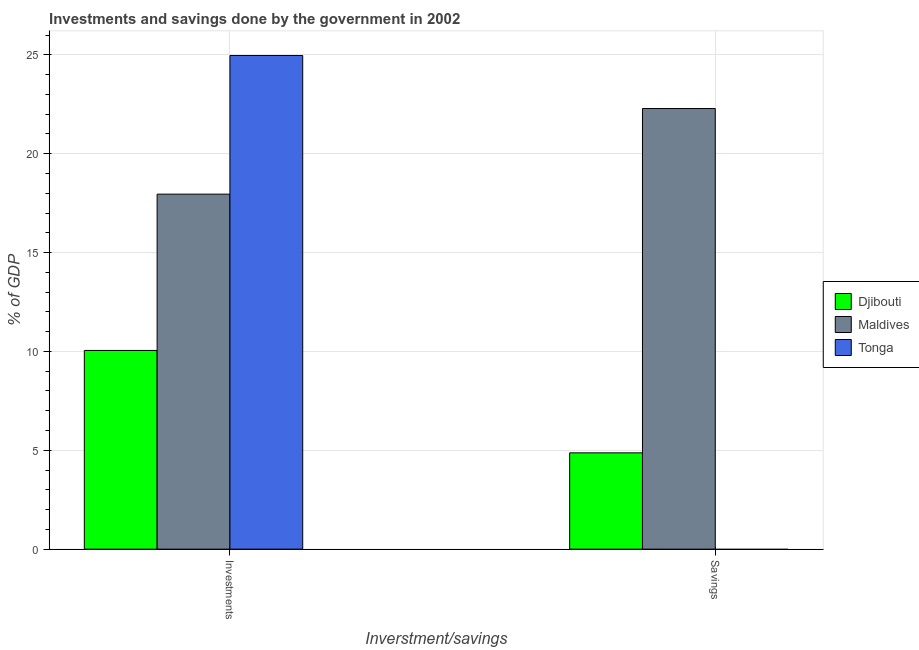How many groups of bars are there?
Provide a short and direct response. 2. Are the number of bars per tick equal to the number of legend labels?
Keep it short and to the point. No. How many bars are there on the 2nd tick from the right?
Offer a very short reply. 3. What is the label of the 2nd group of bars from the left?
Provide a succinct answer. Savings. What is the savings of government in Tonga?
Your response must be concise. 0. Across all countries, what is the maximum savings of government?
Your response must be concise. 22.29. In which country was the investments of government maximum?
Offer a terse response. Tonga. What is the total savings of government in the graph?
Make the answer very short. 27.16. What is the difference between the savings of government in Maldives and that in Djibouti?
Your response must be concise. 17.41. What is the difference between the investments of government in Djibouti and the savings of government in Maldives?
Provide a short and direct response. -12.24. What is the average savings of government per country?
Provide a succinct answer. 9.05. What is the difference between the savings of government and investments of government in Djibouti?
Your answer should be very brief. -5.18. What is the ratio of the savings of government in Maldives to that in Djibouti?
Make the answer very short. 4.57. Does the graph contain grids?
Your answer should be very brief. Yes. Where does the legend appear in the graph?
Your response must be concise. Center right. How many legend labels are there?
Ensure brevity in your answer.  3. How are the legend labels stacked?
Provide a succinct answer. Vertical. What is the title of the graph?
Give a very brief answer. Investments and savings done by the government in 2002. Does "Venezuela" appear as one of the legend labels in the graph?
Make the answer very short. No. What is the label or title of the X-axis?
Keep it short and to the point. Inverstment/savings. What is the label or title of the Y-axis?
Give a very brief answer. % of GDP. What is the % of GDP in Djibouti in Investments?
Offer a terse response. 10.05. What is the % of GDP of Maldives in Investments?
Provide a succinct answer. 17.95. What is the % of GDP of Tonga in Investments?
Ensure brevity in your answer.  24.97. What is the % of GDP of Djibouti in Savings?
Make the answer very short. 4.87. What is the % of GDP in Maldives in Savings?
Offer a terse response. 22.29. What is the % of GDP of Tonga in Savings?
Provide a succinct answer. 0. Across all Inverstment/savings, what is the maximum % of GDP in Djibouti?
Offer a very short reply. 10.05. Across all Inverstment/savings, what is the maximum % of GDP of Maldives?
Offer a terse response. 22.29. Across all Inverstment/savings, what is the maximum % of GDP of Tonga?
Make the answer very short. 24.97. Across all Inverstment/savings, what is the minimum % of GDP in Djibouti?
Provide a short and direct response. 4.87. Across all Inverstment/savings, what is the minimum % of GDP in Maldives?
Provide a short and direct response. 17.95. What is the total % of GDP in Djibouti in the graph?
Your response must be concise. 14.92. What is the total % of GDP in Maldives in the graph?
Make the answer very short. 40.24. What is the total % of GDP of Tonga in the graph?
Provide a succinct answer. 24.97. What is the difference between the % of GDP in Djibouti in Investments and that in Savings?
Offer a terse response. 5.18. What is the difference between the % of GDP of Maldives in Investments and that in Savings?
Ensure brevity in your answer.  -4.33. What is the difference between the % of GDP of Djibouti in Investments and the % of GDP of Maldives in Savings?
Your answer should be compact. -12.24. What is the average % of GDP in Djibouti per Inverstment/savings?
Your answer should be compact. 7.46. What is the average % of GDP of Maldives per Inverstment/savings?
Your answer should be compact. 20.12. What is the average % of GDP of Tonga per Inverstment/savings?
Your response must be concise. 12.48. What is the difference between the % of GDP of Djibouti and % of GDP of Maldives in Investments?
Provide a succinct answer. -7.91. What is the difference between the % of GDP of Djibouti and % of GDP of Tonga in Investments?
Provide a short and direct response. -14.92. What is the difference between the % of GDP in Maldives and % of GDP in Tonga in Investments?
Give a very brief answer. -7.01. What is the difference between the % of GDP in Djibouti and % of GDP in Maldives in Savings?
Keep it short and to the point. -17.41. What is the ratio of the % of GDP in Djibouti in Investments to that in Savings?
Your answer should be compact. 2.06. What is the ratio of the % of GDP of Maldives in Investments to that in Savings?
Offer a very short reply. 0.81. What is the difference between the highest and the second highest % of GDP of Djibouti?
Your answer should be very brief. 5.18. What is the difference between the highest and the second highest % of GDP in Maldives?
Provide a succinct answer. 4.33. What is the difference between the highest and the lowest % of GDP of Djibouti?
Make the answer very short. 5.18. What is the difference between the highest and the lowest % of GDP in Maldives?
Keep it short and to the point. 4.33. What is the difference between the highest and the lowest % of GDP in Tonga?
Keep it short and to the point. 24.97. 